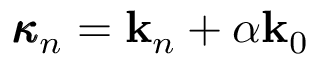Convert formula to latex. <formula><loc_0><loc_0><loc_500><loc_500>\pm b { \kappa } _ { n } = k _ { n } + \alpha k _ { 0 }</formula> 